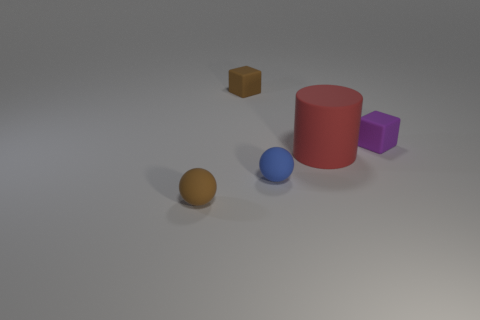Add 1 large objects. How many objects exist? 6 Subtract all blocks. How many objects are left? 3 Add 1 big rubber cylinders. How many big rubber cylinders exist? 2 Subtract 0 purple cylinders. How many objects are left? 5 Subtract all large red rubber cylinders. Subtract all tiny blocks. How many objects are left? 2 Add 5 red cylinders. How many red cylinders are left? 6 